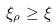Convert formula to latex. <formula><loc_0><loc_0><loc_500><loc_500>\xi _ { \rho } \geq \xi</formula> 